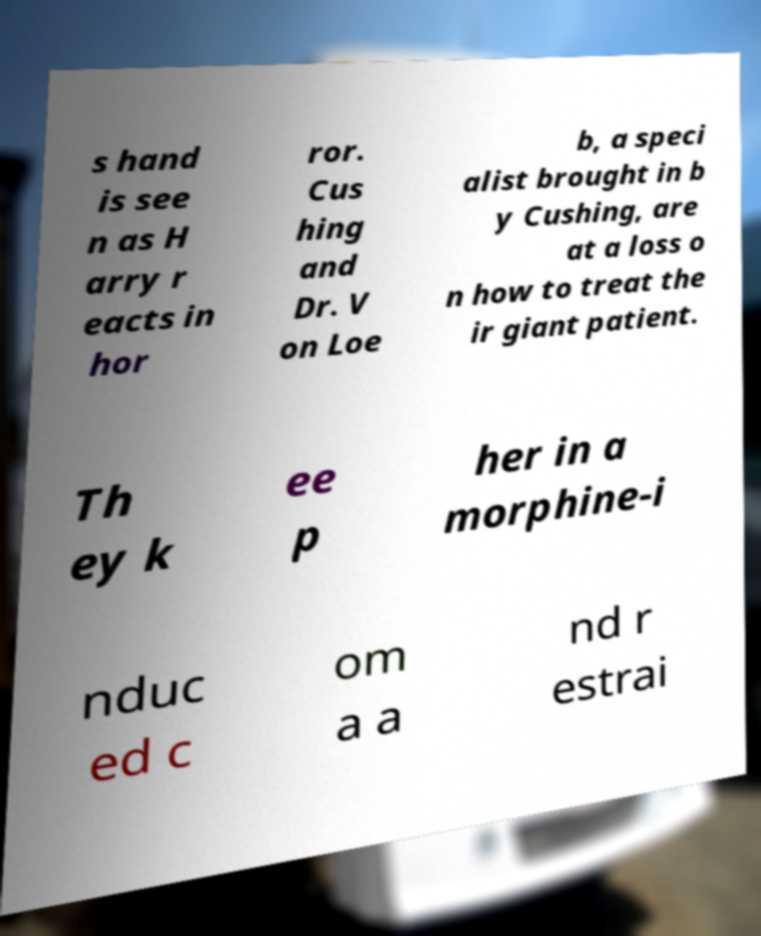Please read and relay the text visible in this image. What does it say? s hand is see n as H arry r eacts in hor ror. Cus hing and Dr. V on Loe b, a speci alist brought in b y Cushing, are at a loss o n how to treat the ir giant patient. Th ey k ee p her in a morphine-i nduc ed c om a a nd r estrai 